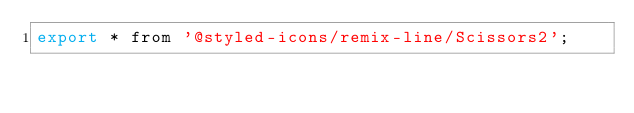Convert code to text. <code><loc_0><loc_0><loc_500><loc_500><_JavaScript_>export * from '@styled-icons/remix-line/Scissors2';
</code> 